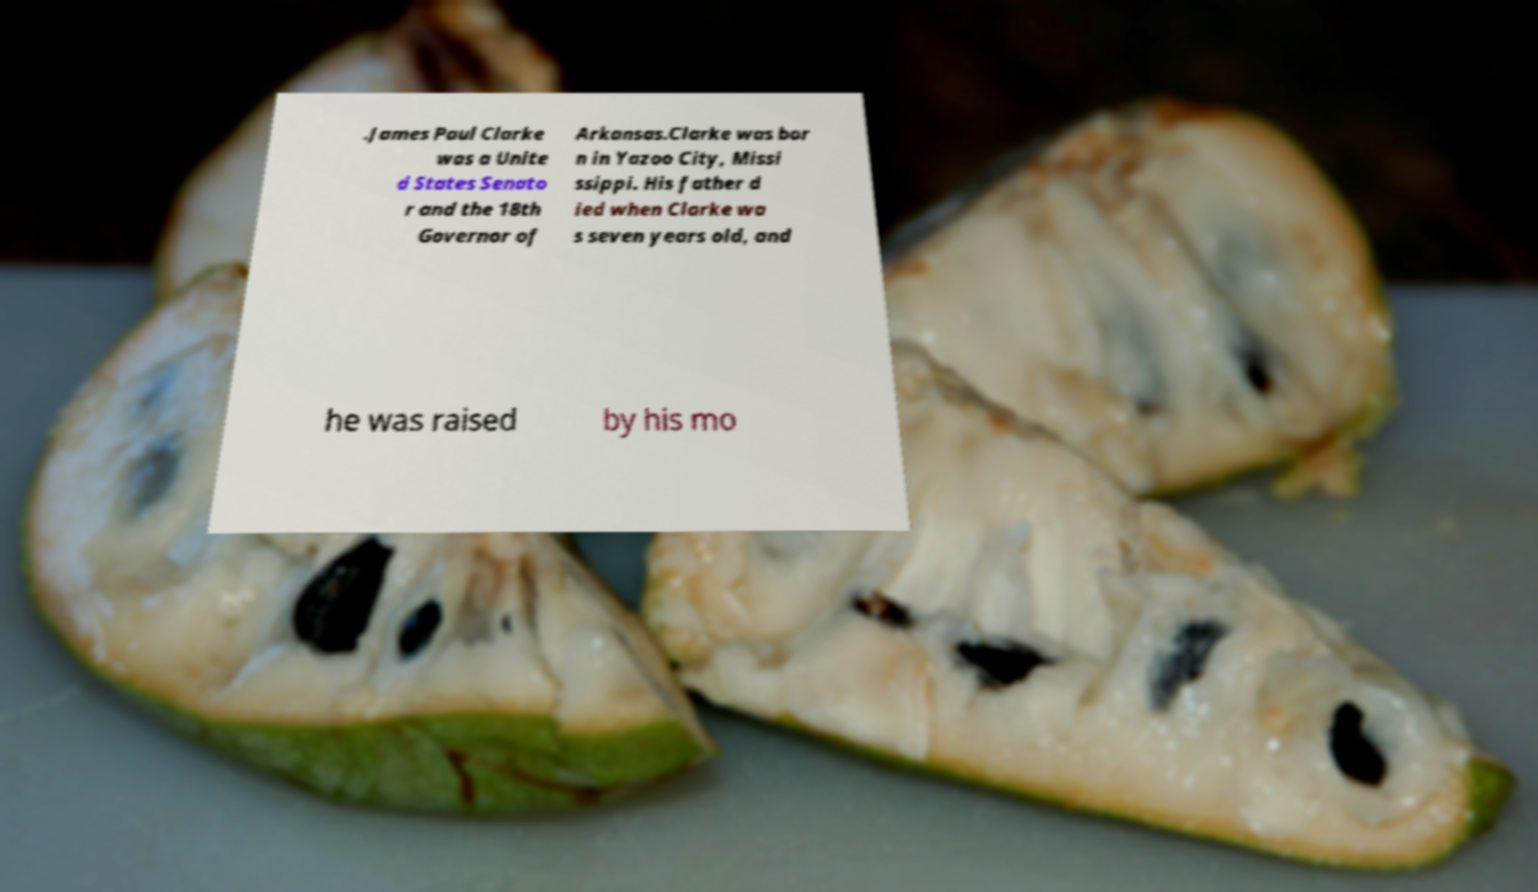What messages or text are displayed in this image? I need them in a readable, typed format. .James Paul Clarke was a Unite d States Senato r and the 18th Governor of Arkansas.Clarke was bor n in Yazoo City, Missi ssippi. His father d ied when Clarke wa s seven years old, and he was raised by his mo 